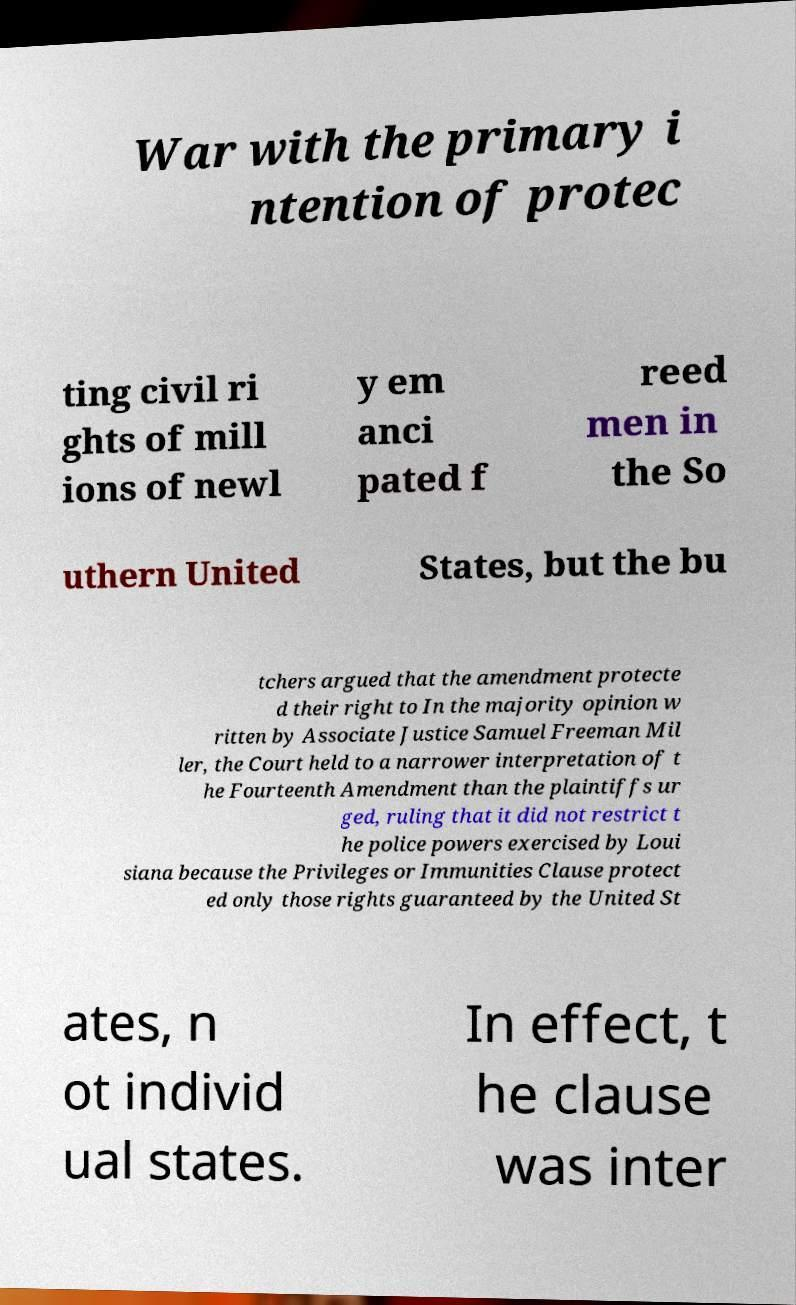There's text embedded in this image that I need extracted. Can you transcribe it verbatim? War with the primary i ntention of protec ting civil ri ghts of mill ions of newl y em anci pated f reed men in the So uthern United States, but the bu tchers argued that the amendment protecte d their right to In the majority opinion w ritten by Associate Justice Samuel Freeman Mil ler, the Court held to a narrower interpretation of t he Fourteenth Amendment than the plaintiffs ur ged, ruling that it did not restrict t he police powers exercised by Loui siana because the Privileges or Immunities Clause protect ed only those rights guaranteed by the United St ates, n ot individ ual states. In effect, t he clause was inter 